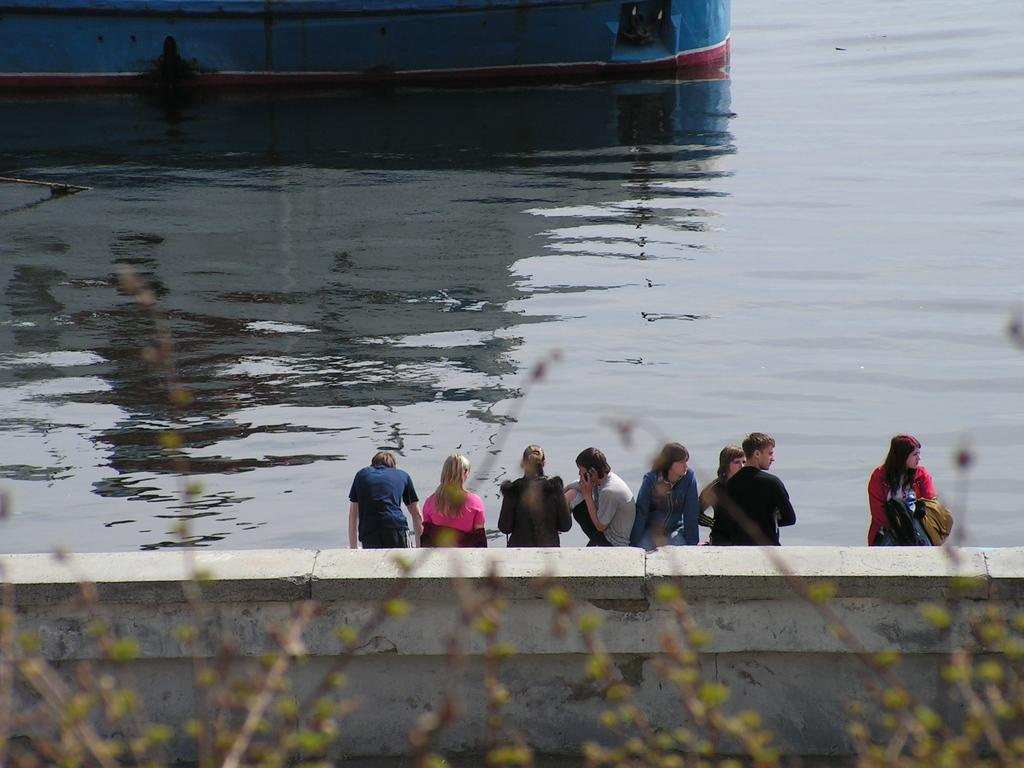What type of natural elements can be seen in the image? There are trees in the image. What man-made structure is visible in the image? There is a wall in the image. Can you describe the people in the image? There are persons standing in the image. What can be seen in the background of the image? There is water visible in the background of the image. What is the color of the object floating on the water? The object on the water has blue, white, and red colors. How does the beginner handle the hope in the image? There is no reference to a beginner or hope in the image; it features trees, a wall, persons, water, and a colored object on the water. 